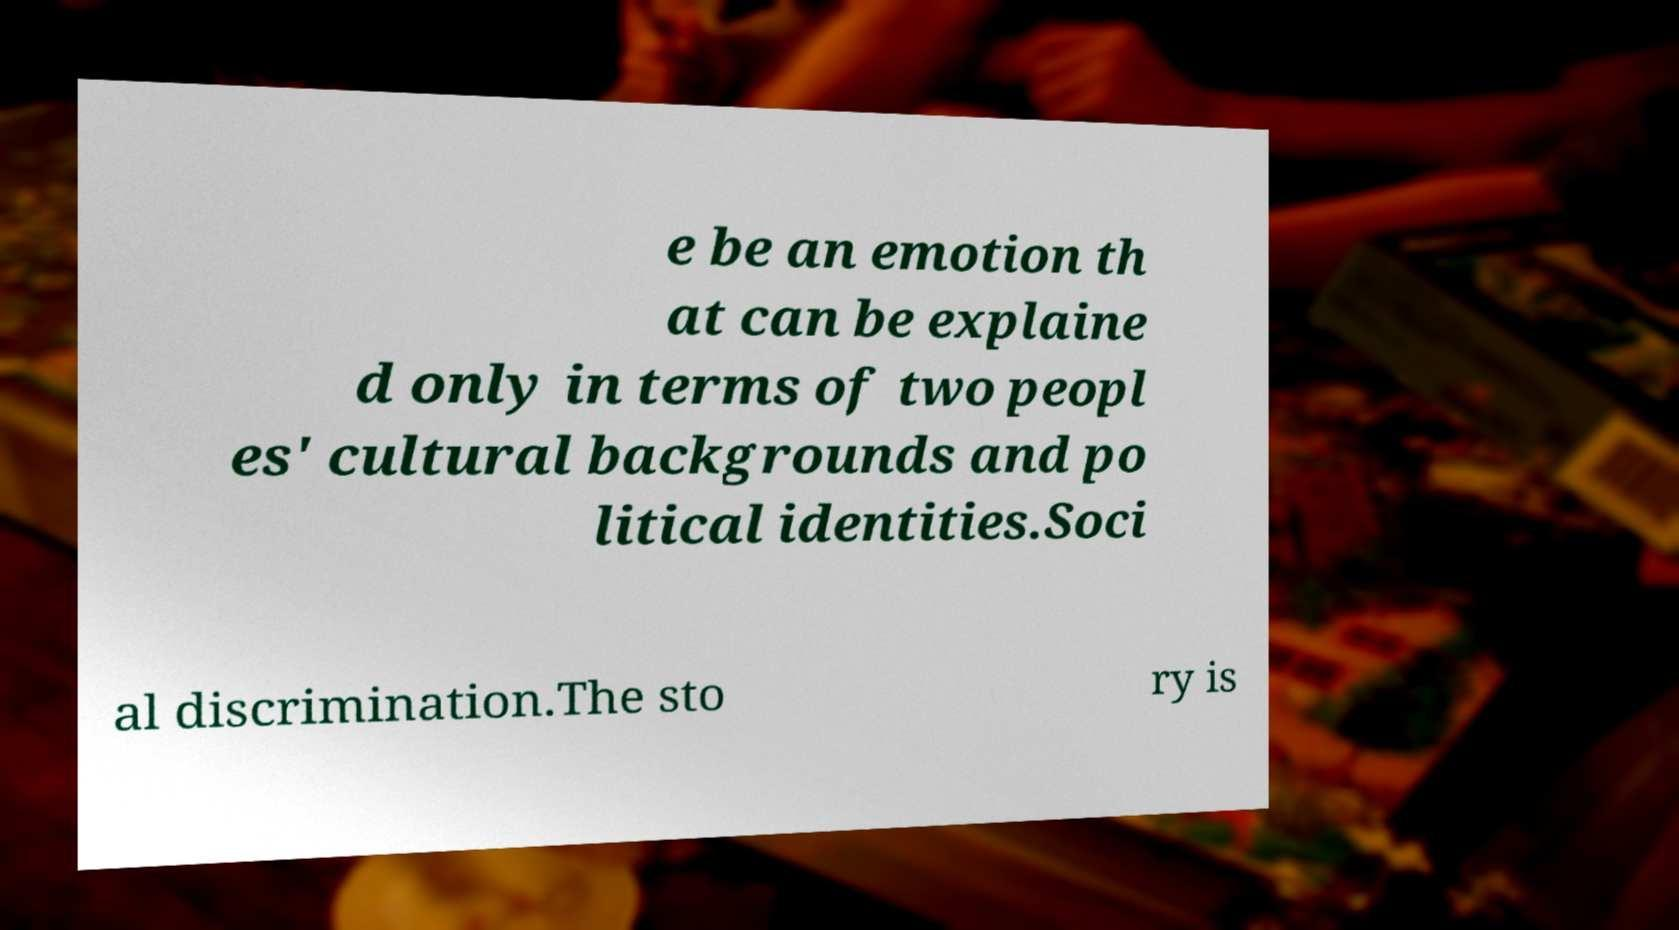I need the written content from this picture converted into text. Can you do that? e be an emotion th at can be explaine d only in terms of two peopl es' cultural backgrounds and po litical identities.Soci al discrimination.The sto ry is 